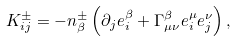<formula> <loc_0><loc_0><loc_500><loc_500>K _ { i j } ^ { \pm } = - n _ { \beta } ^ { \pm } \left ( \partial _ { j } e _ { i } ^ { \beta } + \Gamma _ { \mu \nu } ^ { \beta } e _ { i } ^ { \mu } e _ { j } ^ { \nu } \right ) ,</formula> 